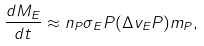Convert formula to latex. <formula><loc_0><loc_0><loc_500><loc_500>\frac { d M _ { E } } { d t } \approx n _ { P } \sigma _ { E } P ( \Delta v _ { E } P ) m _ { P } , \label H { e q \colon d M d t - 1 }</formula> 